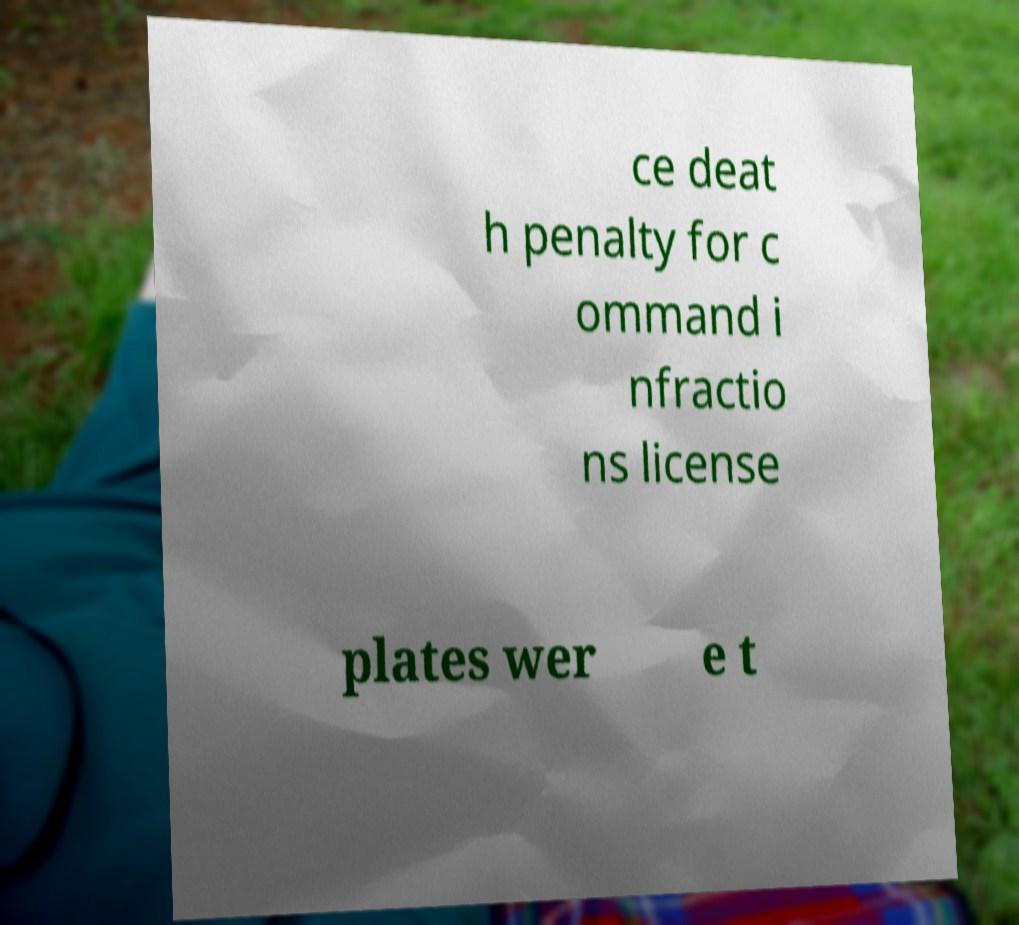Could you assist in decoding the text presented in this image and type it out clearly? ce deat h penalty for c ommand i nfractio ns license plates wer e t 